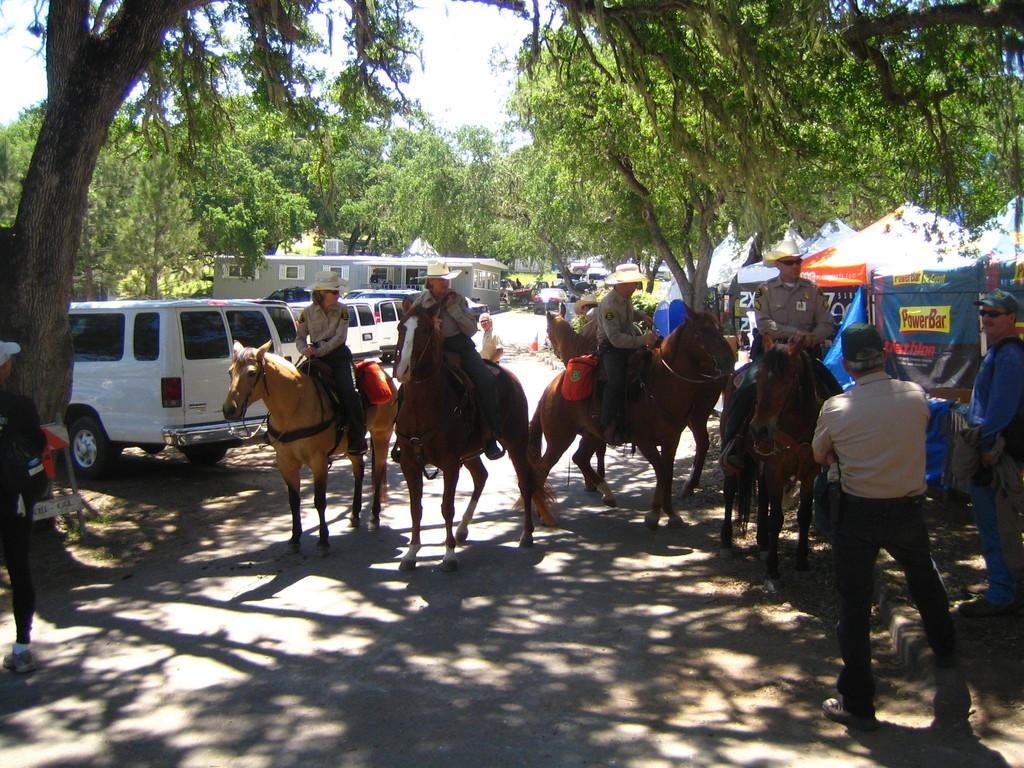How many people are on the horse in the image? There are four people on the horse in the image. What is happening on the right side of the image? There are two people standing on the right side. What can be seen in the background of the image? There are three cars and trees in the background. What type of sponge is being used for punishment in the image? There is no sponge or punishment present in the image. How does the horse fall in the image? The horse does not fall in the image; it is carrying four people. 